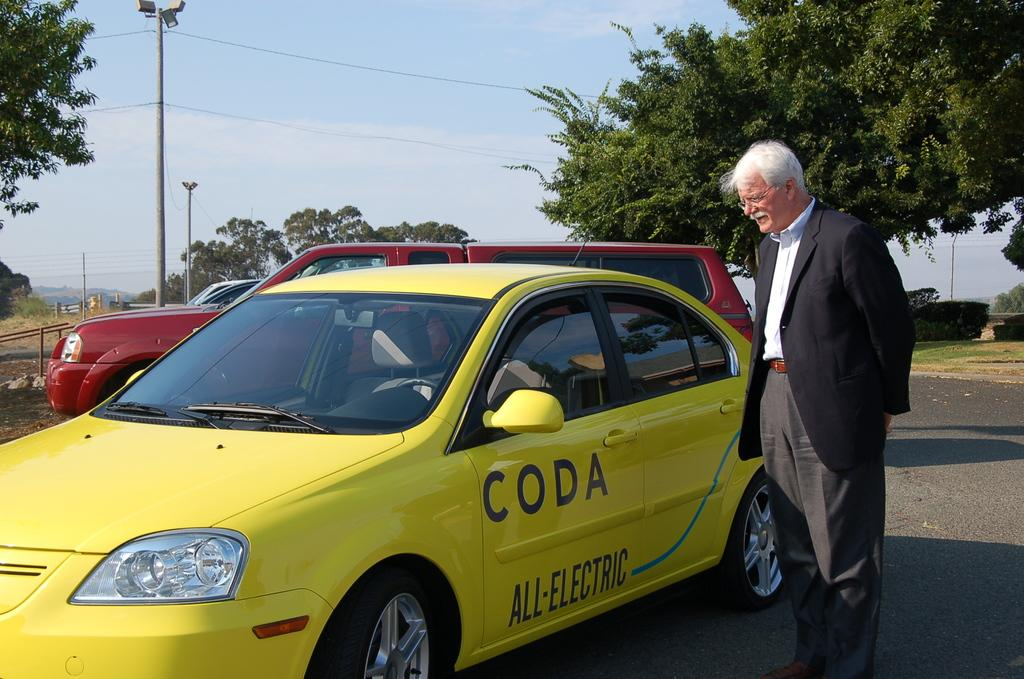<image>
Render a clear and concise summary of the photo. A man looks at a yellow car that is all electric and made by CODA. 